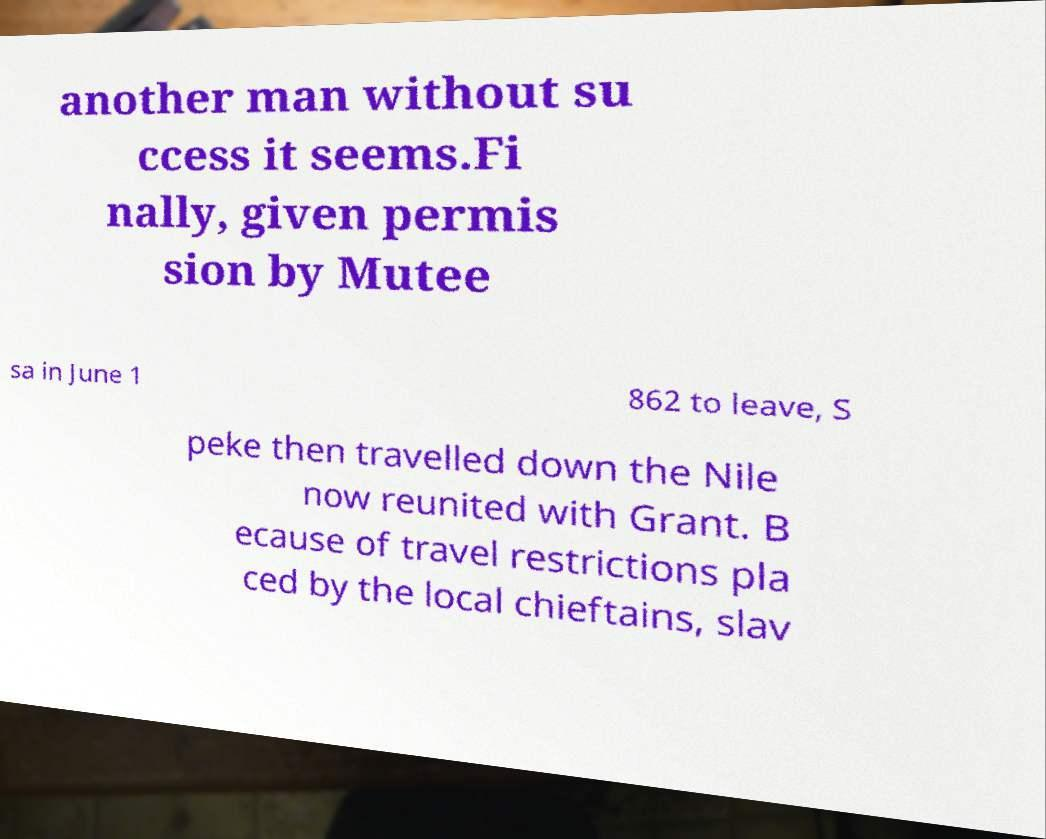I need the written content from this picture converted into text. Can you do that? another man without su ccess it seems.Fi nally, given permis sion by Mutee sa in June 1 862 to leave, S peke then travelled down the Nile now reunited with Grant. B ecause of travel restrictions pla ced by the local chieftains, slav 